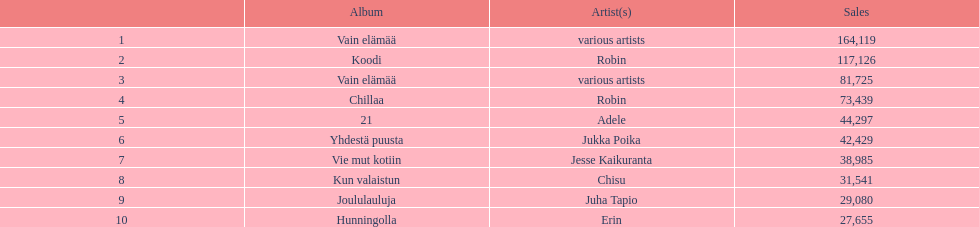What's the combined sales count for the top 10 best-selling albums? 650396. 